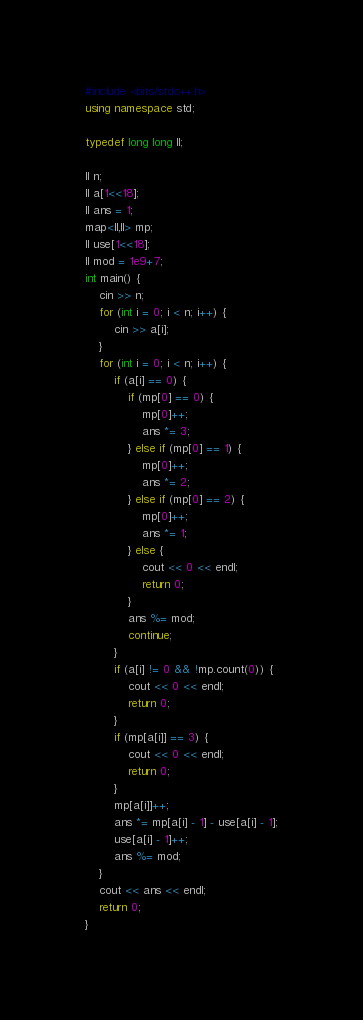<code> <loc_0><loc_0><loc_500><loc_500><_C++_>#include <bits/stdc++.h>
using namespace std;

typedef long long ll;

ll n;
ll a[1<<18];
ll ans = 1;
map<ll,ll> mp;
ll use[1<<18];
ll mod = 1e9+7;
int main() {
    cin >> n;
    for (int i = 0; i < n; i++) {
        cin >> a[i];
    }
    for (int i = 0; i < n; i++) {
        if (a[i] == 0) {
            if (mp[0] == 0) {
                mp[0]++;
                ans *= 3;
            } else if (mp[0] == 1) {
                mp[0]++;
                ans *= 2;
            } else if (mp[0] == 2) {
                mp[0]++;
                ans *= 1;
            } else {
                cout << 0 << endl;
                return 0;
            }
            ans %= mod;
            continue;
        }
        if (a[i] != 0 && !mp.count(0)) {
            cout << 0 << endl;
            return 0;
        }
        if (mp[a[i]] == 3) {
            cout << 0 << endl;
            return 0;
        }
        mp[a[i]]++;
        ans *= mp[a[i] - 1] - use[a[i] - 1];
        use[a[i] - 1]++;
        ans %= mod;
    }
    cout << ans << endl;
    return 0;
}
</code> 